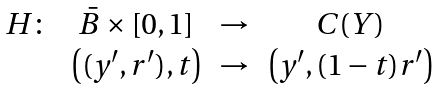Convert formula to latex. <formula><loc_0><loc_0><loc_500><loc_500>\begin{array} { r c c c } H \colon & \bar { B } \times [ 0 , 1 ] & \rightarrow & C ( Y ) \\ & \left ( ( y ^ { \prime } , r ^ { \prime } ) , t \right ) & \rightarrow & \left ( y ^ { \prime } , ( 1 - t ) r ^ { \prime } \right ) \\ \end{array}</formula> 